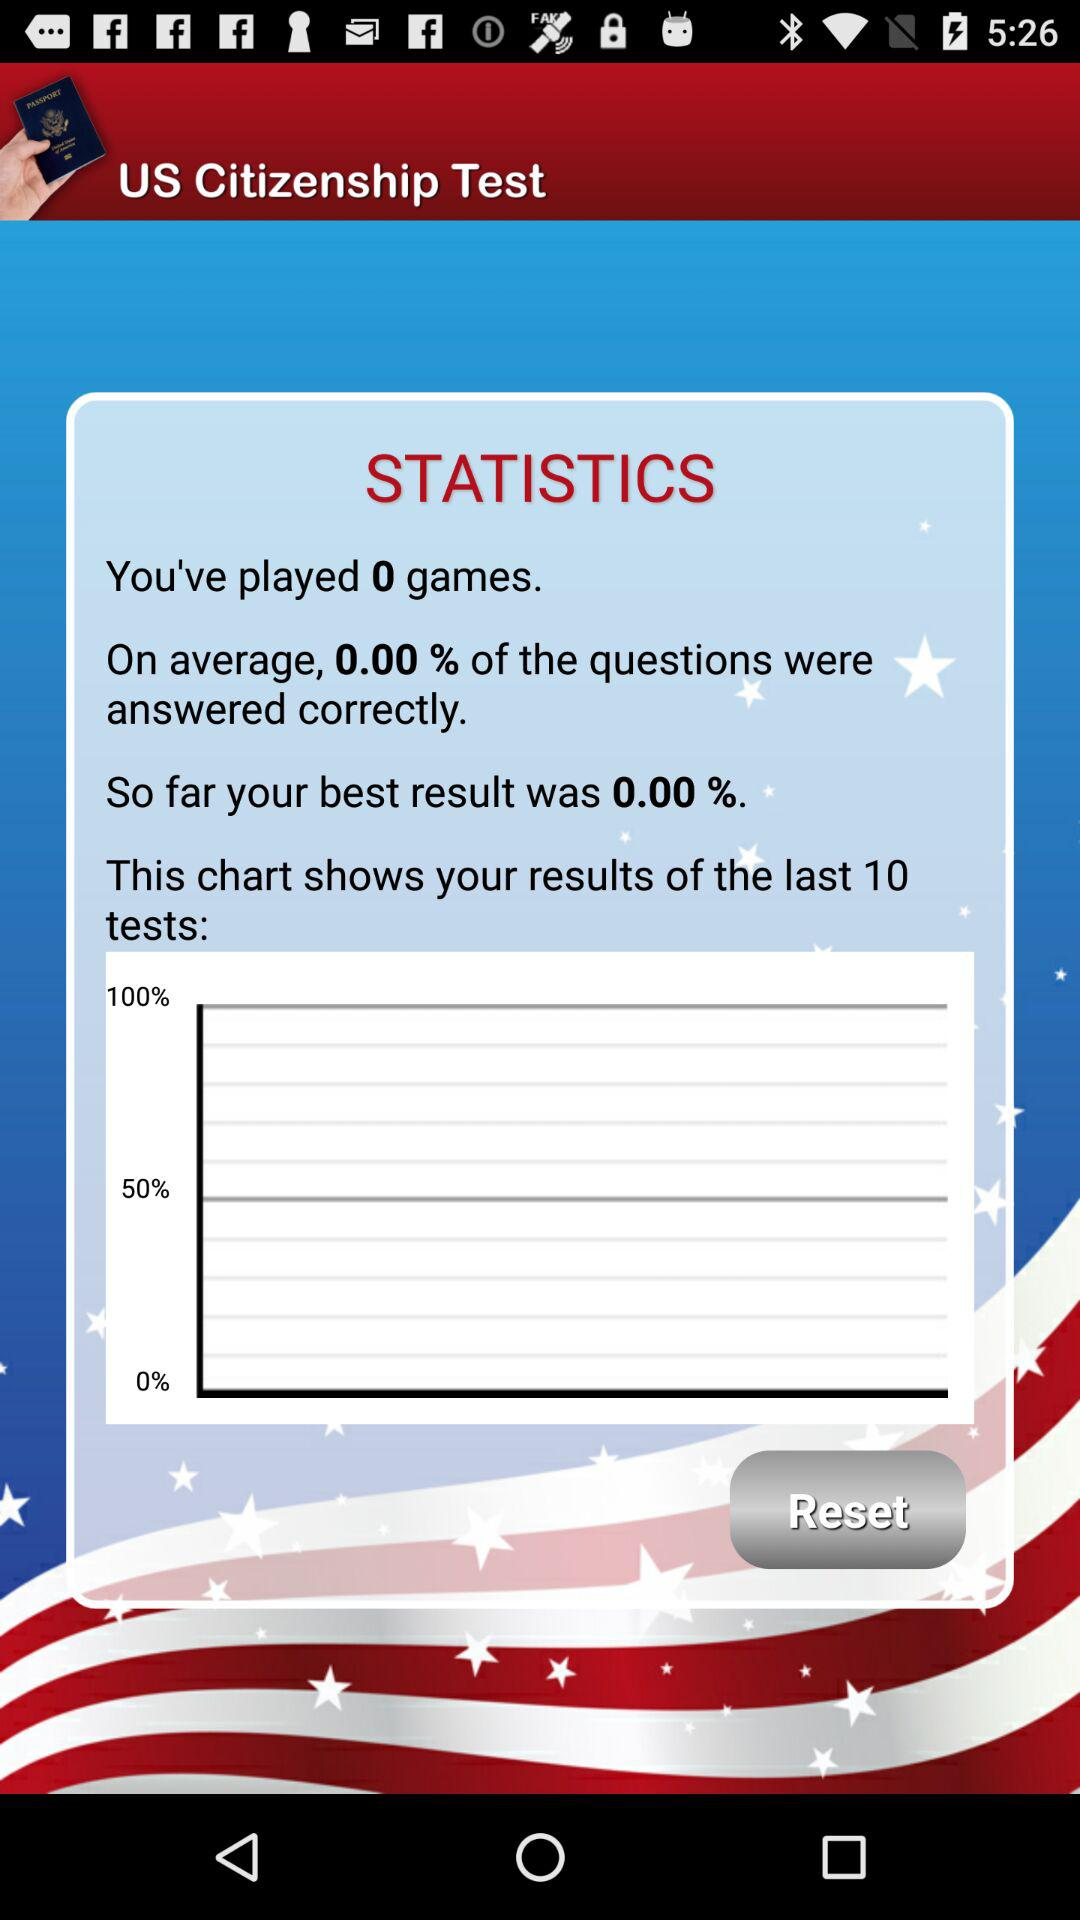What is the count for the games I have played? The count for the games you have played is 0. 